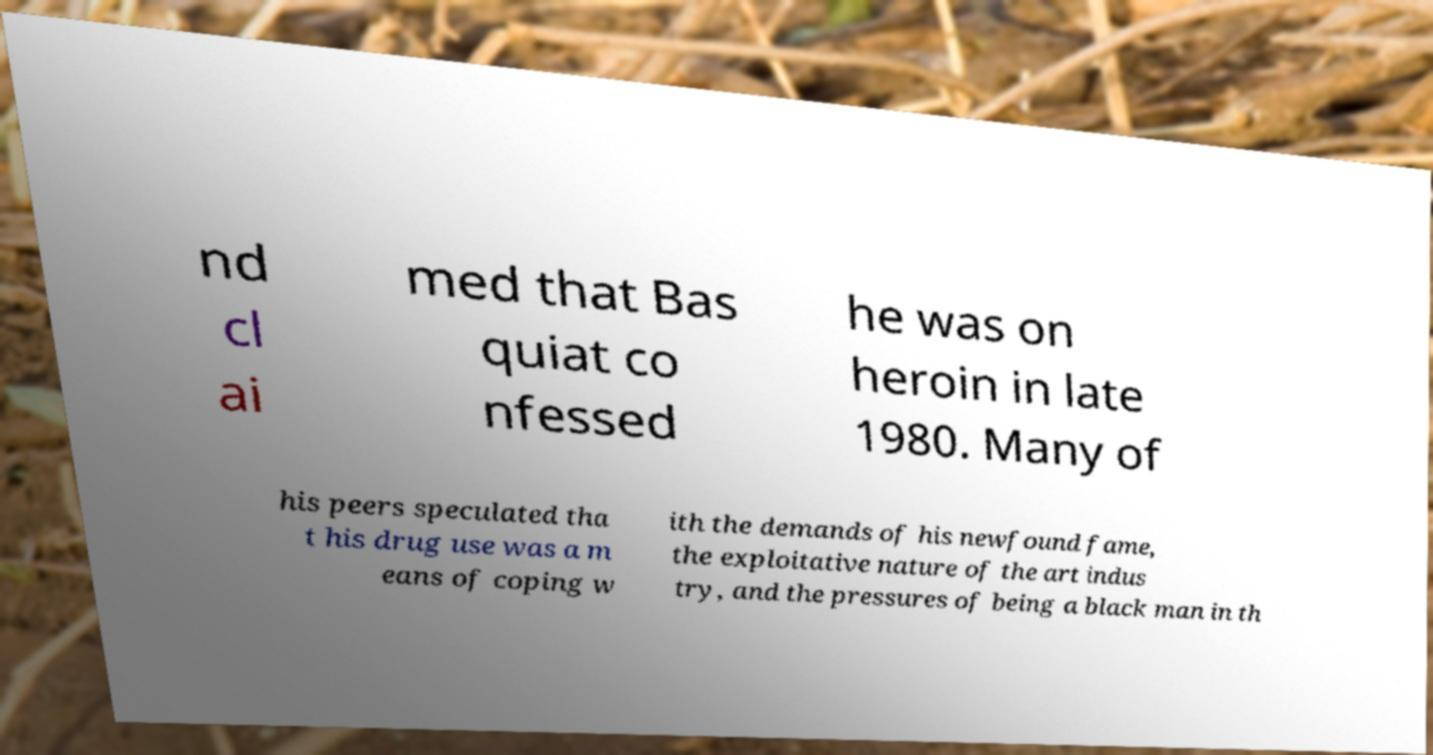There's text embedded in this image that I need extracted. Can you transcribe it verbatim? nd cl ai med that Bas quiat co nfessed he was on heroin in late 1980. Many of his peers speculated tha t his drug use was a m eans of coping w ith the demands of his newfound fame, the exploitative nature of the art indus try, and the pressures of being a black man in th 